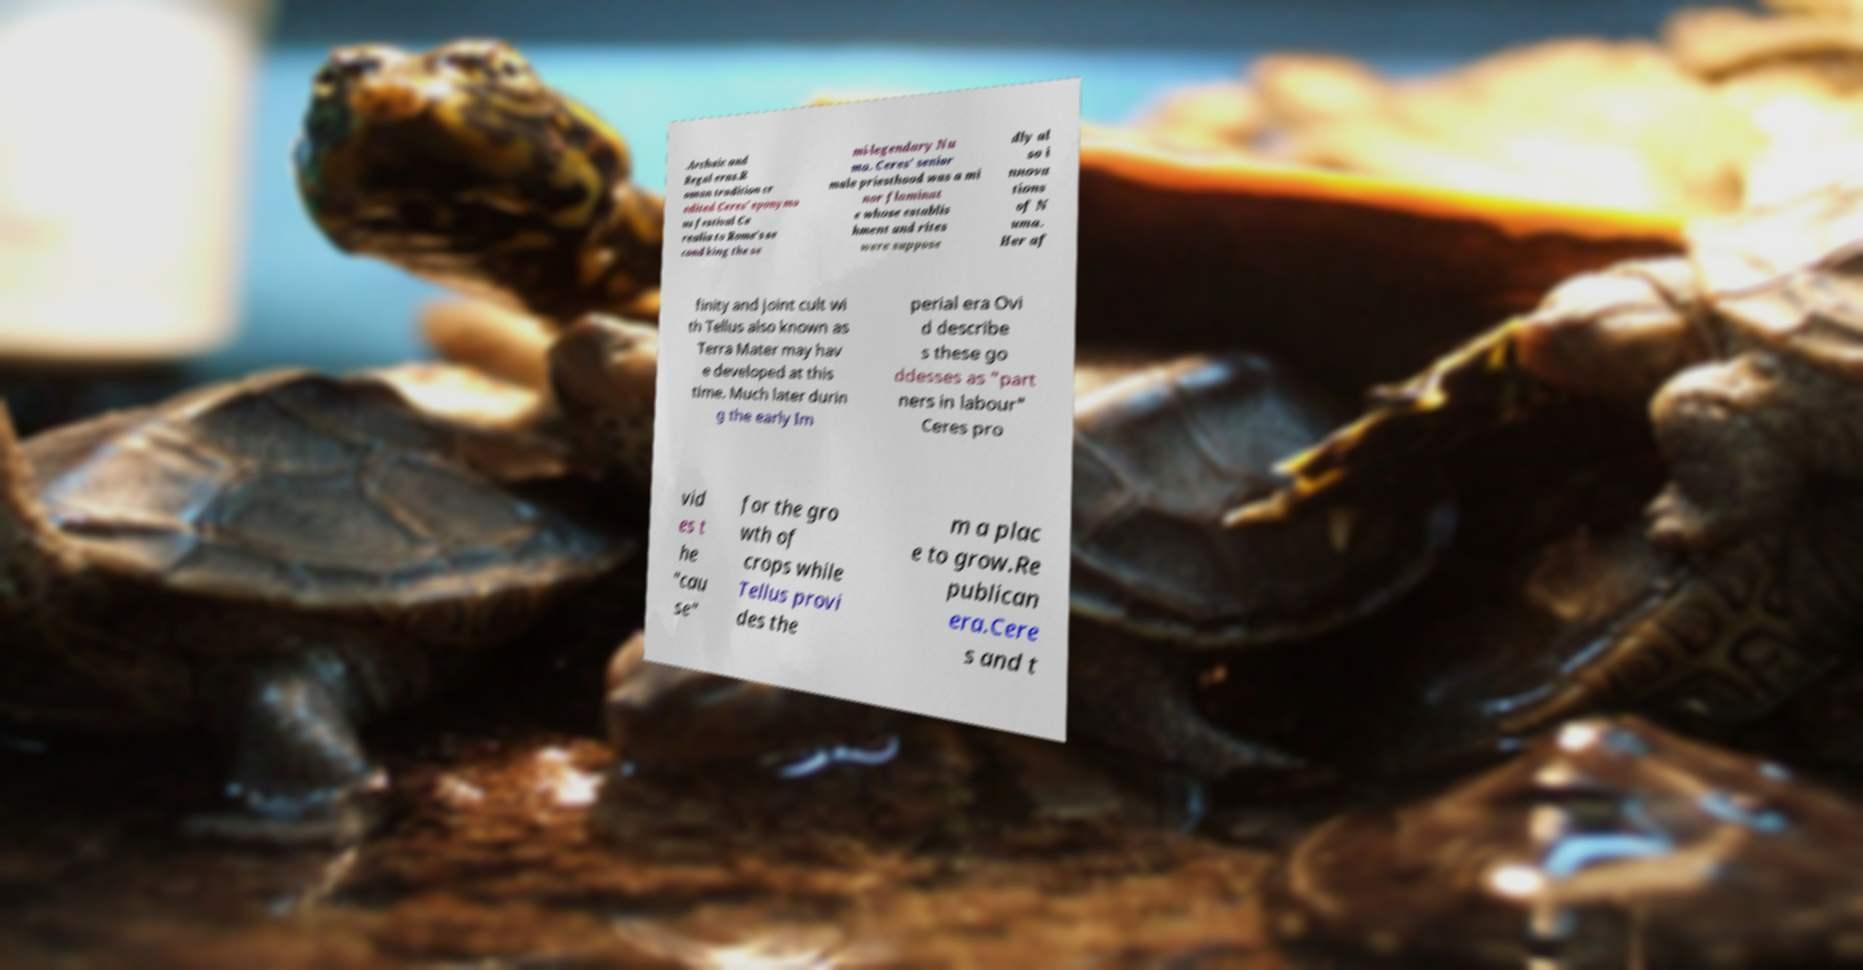For documentation purposes, I need the text within this image transcribed. Could you provide that? .Archaic and Regal eras.R oman tradition cr edited Ceres' eponymo us festival Ce realia to Rome's se cond king the se mi-legendary Nu ma. Ceres' senior male priesthood was a mi nor flaminat e whose establis hment and rites were suppose dly al so i nnova tions of N uma. Her af finity and joint cult wi th Tellus also known as Terra Mater may hav e developed at this time. Much later durin g the early Im perial era Ovi d describe s these go ddesses as "part ners in labour" Ceres pro vid es t he "cau se" for the gro wth of crops while Tellus provi des the m a plac e to grow.Re publican era.Cere s and t 